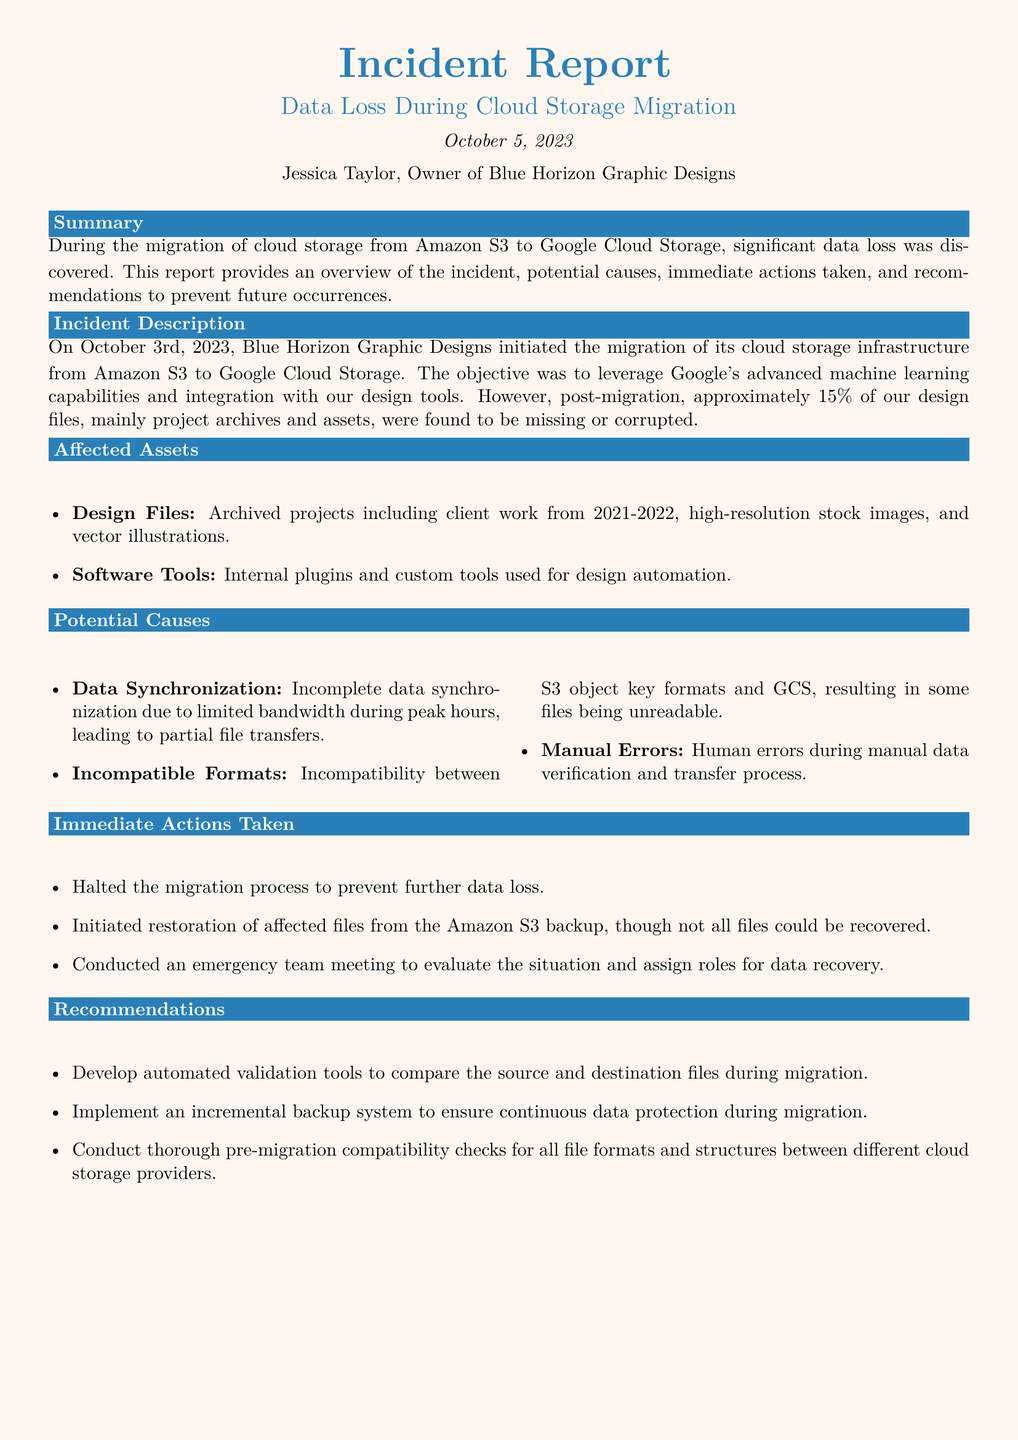What was the date of the incident report? The date of the incident report is stated clearly at the beginning of the document.
Answer: October 5, 2023 What percentage of design files were missing or corrupted? The document specifies the extent of data loss regarding design files post-migration.
Answer: 15% Who is the owner of Blue Horizon Graphic Designs? The name of the agency owner is mentioned at the start of the document.
Answer: Jessica Taylor What type of data experienced issues during the migration? The document lists the affected assets and describes what specific types of data were lost or corrupted.
Answer: Design Files What immediate action was taken to prevent further data loss? The document outlines specific actions taken immediately after discovering data loss.
Answer: Halted the migration process What was one potential cause of the data loss mentioned? The report identifies potential causes for the incident, one of which is specifically noted.
Answer: Data Synchronization What does the report recommend for ensuring data protection during migration? The recommendations section suggests a method to secure data during the migration process.
Answer: Incremental backup system What tool does the report suggest developing for better migration validation? The recommendations provide a specific suggestion for a tool that would help the migration process.
Answer: Automated validation tools 